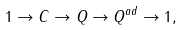Convert formula to latex. <formula><loc_0><loc_0><loc_500><loc_500>1 \to C \to Q \to Q ^ { a d } \to 1 ,</formula> 